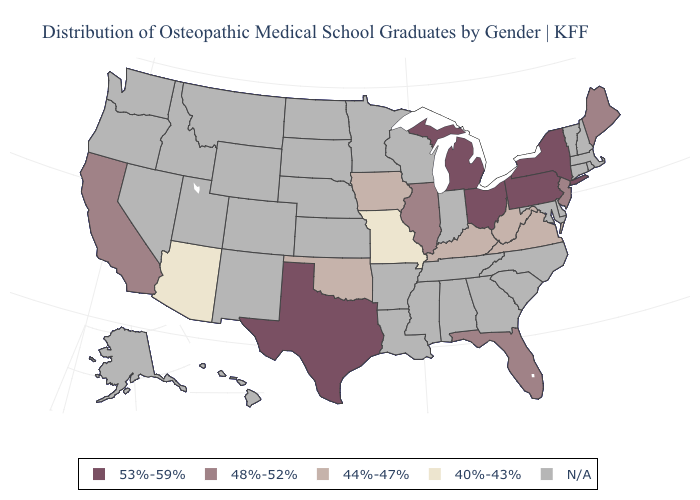Among the states that border New York , which have the highest value?
Keep it brief. Pennsylvania. Does Pennsylvania have the highest value in the Northeast?
Concise answer only. Yes. Name the states that have a value in the range 40%-43%?
Write a very short answer. Arizona, Missouri. Does Arizona have the lowest value in the USA?
Quick response, please. Yes. How many symbols are there in the legend?
Answer briefly. 5. Name the states that have a value in the range 53%-59%?
Be succinct. Michigan, New York, Ohio, Pennsylvania, Texas. What is the lowest value in the USA?
Quick response, please. 40%-43%. What is the value of Vermont?
Short answer required. N/A. What is the highest value in states that border Utah?
Give a very brief answer. 40%-43%. Is the legend a continuous bar?
Write a very short answer. No. What is the highest value in the MidWest ?
Quick response, please. 53%-59%. What is the highest value in the USA?
Keep it brief. 53%-59%. How many symbols are there in the legend?
Give a very brief answer. 5. 